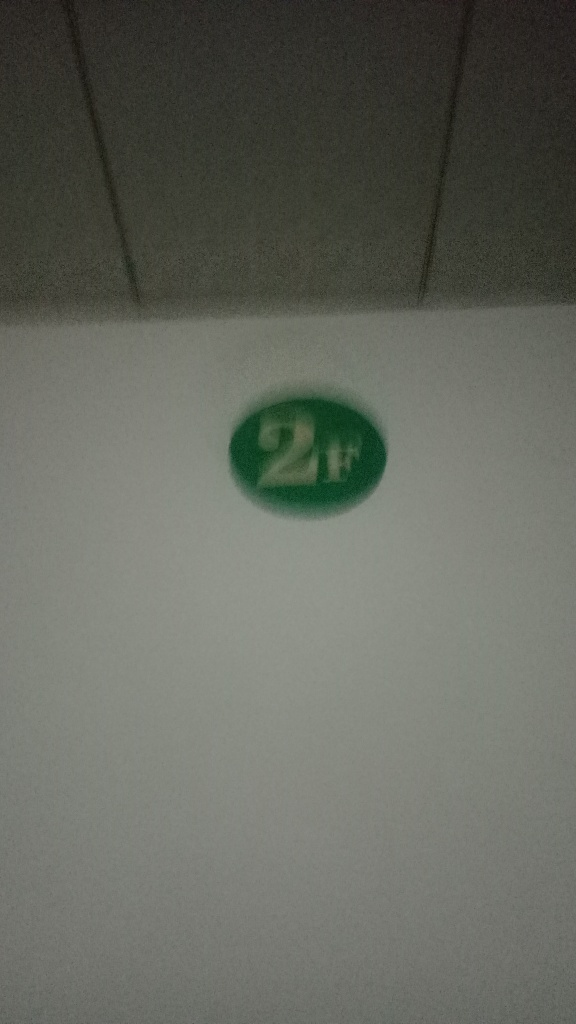Are there any quality issues with this image? Yes, there are several quality issues with this image, including significant blurriness, poor lighting conditions that create a dark environment, a lack of focus, and no clear subject matter which makes it difficult to discern the details or context of the scene portrayed by the image. 